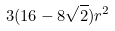<formula> <loc_0><loc_0><loc_500><loc_500>3 ( 1 6 - 8 \sqrt { 2 } ) r ^ { 2 }</formula> 